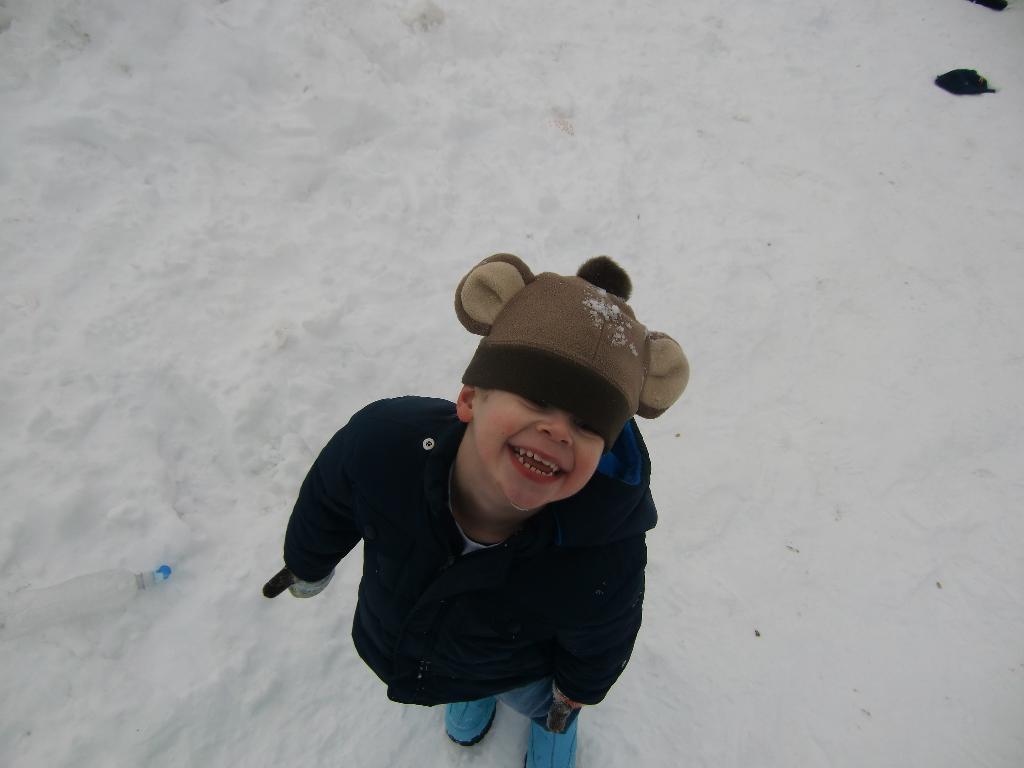How would you summarize this image in a sentence or two? In this picture I can see a kid standing on the snow and there are some objects. 